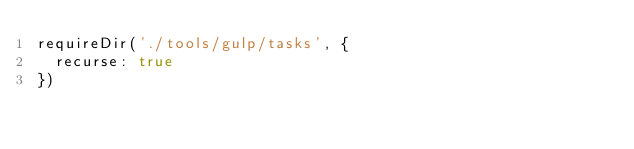<code> <loc_0><loc_0><loc_500><loc_500><_JavaScript_>requireDir('./tools/gulp/tasks', {
  recurse: true
})
</code> 